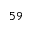<formula> <loc_0><loc_0><loc_500><loc_500>^ { 5 9 }</formula> 